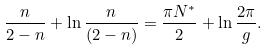Convert formula to latex. <formula><loc_0><loc_0><loc_500><loc_500>\frac { n } { 2 - n } + \ln { \frac { n } { ( 2 - n ) } } = \frac { \pi N ^ { * } } { 2 } + \ln { \frac { 2 \pi } { g } } .</formula> 